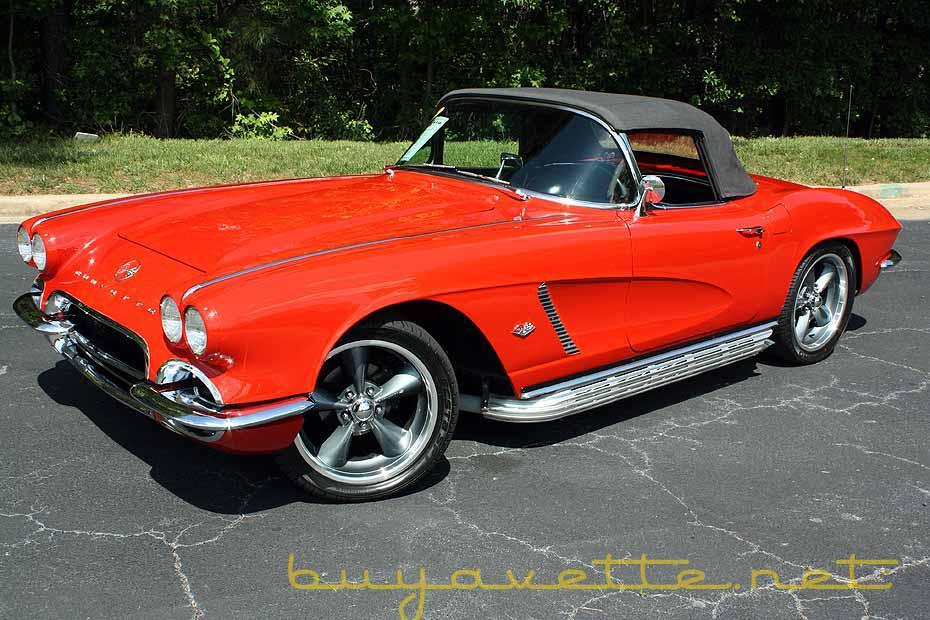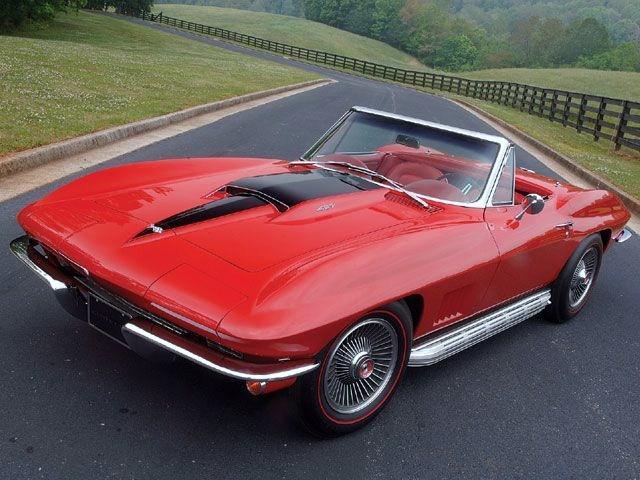The first image is the image on the left, the second image is the image on the right. Considering the images on both sides, is "One of the corvettes is on the road." valid? Answer yes or no. Yes. The first image is the image on the left, the second image is the image on the right. Given the left and right images, does the statement "The left image features a rightward-angled dark red convertible with its top covered, and the right image shows a leftward-facing dark red convertible with its top down." hold true? Answer yes or no. No. 